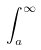Convert formula to latex. <formula><loc_0><loc_0><loc_500><loc_500>\int _ { a } ^ { \infty }</formula> 